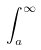Convert formula to latex. <formula><loc_0><loc_0><loc_500><loc_500>\int _ { a } ^ { \infty }</formula> 